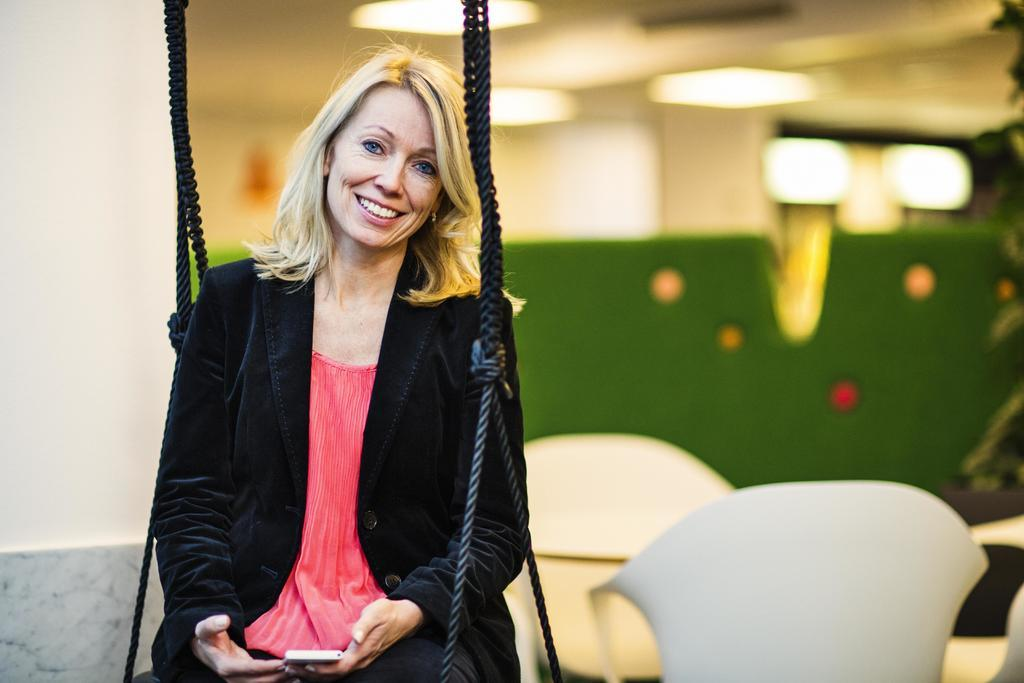Who is the main subject in the image? There is a woman in the image. What is the woman doing in the image? The woman is sitting on a swing. What object is the woman holding in her hand? The woman is holding a mobile phone in her hand. What type of furniture can be seen in the image? There are chairs visible in the image. What type of cheese is the woman eating on the swing? There is no cheese present in the image; the woman is holding a mobile phone. What shape is the advice given by the woman on the swing? There is no advice being given in the image, and therefore no shape can be determined. 